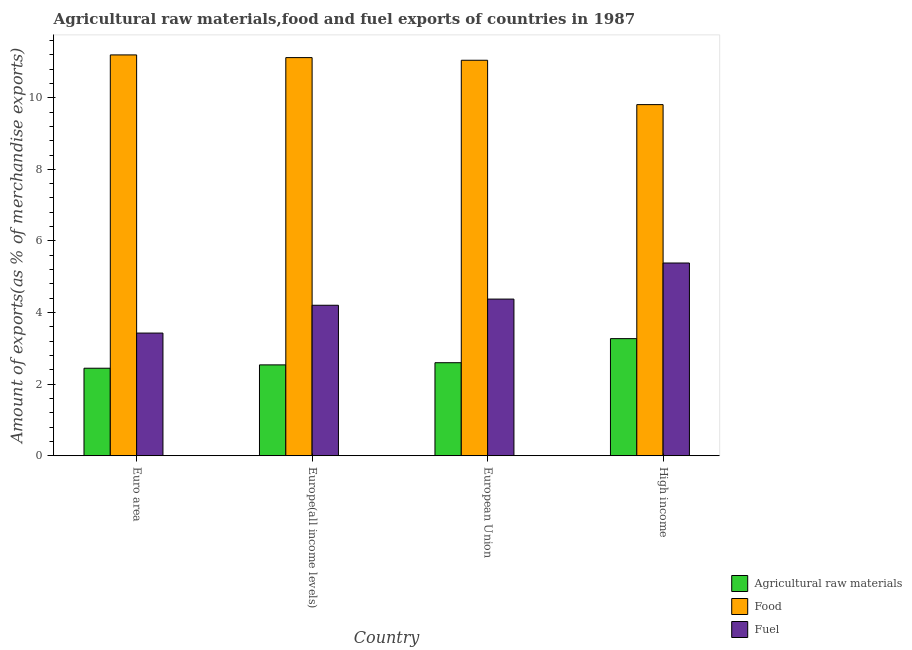How many different coloured bars are there?
Offer a very short reply. 3. Are the number of bars per tick equal to the number of legend labels?
Your answer should be compact. Yes. In how many cases, is the number of bars for a given country not equal to the number of legend labels?
Make the answer very short. 0. What is the percentage of raw materials exports in High income?
Provide a succinct answer. 3.27. Across all countries, what is the maximum percentage of fuel exports?
Keep it short and to the point. 5.38. Across all countries, what is the minimum percentage of food exports?
Offer a terse response. 9.81. In which country was the percentage of fuel exports maximum?
Provide a short and direct response. High income. In which country was the percentage of fuel exports minimum?
Ensure brevity in your answer.  Euro area. What is the total percentage of fuel exports in the graph?
Your answer should be compact. 17.39. What is the difference between the percentage of raw materials exports in Europe(all income levels) and that in High income?
Offer a very short reply. -0.73. What is the difference between the percentage of raw materials exports in European Union and the percentage of fuel exports in Europe(all income levels)?
Offer a very short reply. -1.6. What is the average percentage of food exports per country?
Your response must be concise. 10.79. What is the difference between the percentage of food exports and percentage of fuel exports in European Union?
Provide a succinct answer. 6.67. In how many countries, is the percentage of food exports greater than 8.4 %?
Give a very brief answer. 4. What is the ratio of the percentage of food exports in Europe(all income levels) to that in European Union?
Give a very brief answer. 1.01. Is the percentage of raw materials exports in European Union less than that in High income?
Offer a terse response. Yes. What is the difference between the highest and the second highest percentage of fuel exports?
Keep it short and to the point. 1.01. What is the difference between the highest and the lowest percentage of raw materials exports?
Ensure brevity in your answer.  0.83. What does the 2nd bar from the left in Euro area represents?
Ensure brevity in your answer.  Food. What does the 2nd bar from the right in High income represents?
Provide a succinct answer. Food. How many bars are there?
Offer a very short reply. 12. How many countries are there in the graph?
Your answer should be very brief. 4. What is the difference between two consecutive major ticks on the Y-axis?
Provide a succinct answer. 2. Where does the legend appear in the graph?
Make the answer very short. Bottom right. What is the title of the graph?
Provide a succinct answer. Agricultural raw materials,food and fuel exports of countries in 1987. Does "Poland" appear as one of the legend labels in the graph?
Keep it short and to the point. No. What is the label or title of the Y-axis?
Your response must be concise. Amount of exports(as % of merchandise exports). What is the Amount of exports(as % of merchandise exports) in Agricultural raw materials in Euro area?
Ensure brevity in your answer.  2.44. What is the Amount of exports(as % of merchandise exports) in Food in Euro area?
Ensure brevity in your answer.  11.2. What is the Amount of exports(as % of merchandise exports) in Fuel in Euro area?
Keep it short and to the point. 3.43. What is the Amount of exports(as % of merchandise exports) in Agricultural raw materials in Europe(all income levels)?
Your answer should be very brief. 2.54. What is the Amount of exports(as % of merchandise exports) of Food in Europe(all income levels)?
Make the answer very short. 11.12. What is the Amount of exports(as % of merchandise exports) of Fuel in Europe(all income levels)?
Offer a terse response. 4.2. What is the Amount of exports(as % of merchandise exports) in Agricultural raw materials in European Union?
Provide a short and direct response. 2.6. What is the Amount of exports(as % of merchandise exports) of Food in European Union?
Make the answer very short. 11.05. What is the Amount of exports(as % of merchandise exports) in Fuel in European Union?
Offer a terse response. 4.38. What is the Amount of exports(as % of merchandise exports) in Agricultural raw materials in High income?
Offer a terse response. 3.27. What is the Amount of exports(as % of merchandise exports) of Food in High income?
Provide a succinct answer. 9.81. What is the Amount of exports(as % of merchandise exports) in Fuel in High income?
Your answer should be compact. 5.38. Across all countries, what is the maximum Amount of exports(as % of merchandise exports) of Agricultural raw materials?
Give a very brief answer. 3.27. Across all countries, what is the maximum Amount of exports(as % of merchandise exports) in Food?
Offer a terse response. 11.2. Across all countries, what is the maximum Amount of exports(as % of merchandise exports) of Fuel?
Keep it short and to the point. 5.38. Across all countries, what is the minimum Amount of exports(as % of merchandise exports) of Agricultural raw materials?
Keep it short and to the point. 2.44. Across all countries, what is the minimum Amount of exports(as % of merchandise exports) of Food?
Offer a terse response. 9.81. Across all countries, what is the minimum Amount of exports(as % of merchandise exports) in Fuel?
Make the answer very short. 3.43. What is the total Amount of exports(as % of merchandise exports) in Agricultural raw materials in the graph?
Keep it short and to the point. 10.85. What is the total Amount of exports(as % of merchandise exports) of Food in the graph?
Offer a terse response. 43.17. What is the total Amount of exports(as % of merchandise exports) in Fuel in the graph?
Your response must be concise. 17.39. What is the difference between the Amount of exports(as % of merchandise exports) in Agricultural raw materials in Euro area and that in Europe(all income levels)?
Provide a short and direct response. -0.09. What is the difference between the Amount of exports(as % of merchandise exports) of Food in Euro area and that in Europe(all income levels)?
Provide a short and direct response. 0.07. What is the difference between the Amount of exports(as % of merchandise exports) of Fuel in Euro area and that in Europe(all income levels)?
Ensure brevity in your answer.  -0.78. What is the difference between the Amount of exports(as % of merchandise exports) of Agricultural raw materials in Euro area and that in European Union?
Provide a short and direct response. -0.15. What is the difference between the Amount of exports(as % of merchandise exports) of Food in Euro area and that in European Union?
Provide a short and direct response. 0.15. What is the difference between the Amount of exports(as % of merchandise exports) of Fuel in Euro area and that in European Union?
Offer a very short reply. -0.95. What is the difference between the Amount of exports(as % of merchandise exports) in Agricultural raw materials in Euro area and that in High income?
Ensure brevity in your answer.  -0.83. What is the difference between the Amount of exports(as % of merchandise exports) in Food in Euro area and that in High income?
Provide a succinct answer. 1.39. What is the difference between the Amount of exports(as % of merchandise exports) in Fuel in Euro area and that in High income?
Offer a very short reply. -1.96. What is the difference between the Amount of exports(as % of merchandise exports) in Agricultural raw materials in Europe(all income levels) and that in European Union?
Offer a very short reply. -0.06. What is the difference between the Amount of exports(as % of merchandise exports) in Food in Europe(all income levels) and that in European Union?
Give a very brief answer. 0.07. What is the difference between the Amount of exports(as % of merchandise exports) in Fuel in Europe(all income levels) and that in European Union?
Offer a very short reply. -0.17. What is the difference between the Amount of exports(as % of merchandise exports) of Agricultural raw materials in Europe(all income levels) and that in High income?
Offer a very short reply. -0.73. What is the difference between the Amount of exports(as % of merchandise exports) in Food in Europe(all income levels) and that in High income?
Make the answer very short. 1.31. What is the difference between the Amount of exports(as % of merchandise exports) of Fuel in Europe(all income levels) and that in High income?
Keep it short and to the point. -1.18. What is the difference between the Amount of exports(as % of merchandise exports) of Agricultural raw materials in European Union and that in High income?
Keep it short and to the point. -0.67. What is the difference between the Amount of exports(as % of merchandise exports) of Food in European Union and that in High income?
Provide a succinct answer. 1.24. What is the difference between the Amount of exports(as % of merchandise exports) in Fuel in European Union and that in High income?
Keep it short and to the point. -1.01. What is the difference between the Amount of exports(as % of merchandise exports) of Agricultural raw materials in Euro area and the Amount of exports(as % of merchandise exports) of Food in Europe(all income levels)?
Make the answer very short. -8.68. What is the difference between the Amount of exports(as % of merchandise exports) in Agricultural raw materials in Euro area and the Amount of exports(as % of merchandise exports) in Fuel in Europe(all income levels)?
Keep it short and to the point. -1.76. What is the difference between the Amount of exports(as % of merchandise exports) of Food in Euro area and the Amount of exports(as % of merchandise exports) of Fuel in Europe(all income levels)?
Your answer should be compact. 6.99. What is the difference between the Amount of exports(as % of merchandise exports) in Agricultural raw materials in Euro area and the Amount of exports(as % of merchandise exports) in Food in European Union?
Give a very brief answer. -8.6. What is the difference between the Amount of exports(as % of merchandise exports) of Agricultural raw materials in Euro area and the Amount of exports(as % of merchandise exports) of Fuel in European Union?
Give a very brief answer. -1.93. What is the difference between the Amount of exports(as % of merchandise exports) in Food in Euro area and the Amount of exports(as % of merchandise exports) in Fuel in European Union?
Your response must be concise. 6.82. What is the difference between the Amount of exports(as % of merchandise exports) in Agricultural raw materials in Euro area and the Amount of exports(as % of merchandise exports) in Food in High income?
Ensure brevity in your answer.  -7.36. What is the difference between the Amount of exports(as % of merchandise exports) of Agricultural raw materials in Euro area and the Amount of exports(as % of merchandise exports) of Fuel in High income?
Give a very brief answer. -2.94. What is the difference between the Amount of exports(as % of merchandise exports) in Food in Euro area and the Amount of exports(as % of merchandise exports) in Fuel in High income?
Your answer should be compact. 5.81. What is the difference between the Amount of exports(as % of merchandise exports) of Agricultural raw materials in Europe(all income levels) and the Amount of exports(as % of merchandise exports) of Food in European Union?
Keep it short and to the point. -8.51. What is the difference between the Amount of exports(as % of merchandise exports) of Agricultural raw materials in Europe(all income levels) and the Amount of exports(as % of merchandise exports) of Fuel in European Union?
Ensure brevity in your answer.  -1.84. What is the difference between the Amount of exports(as % of merchandise exports) of Food in Europe(all income levels) and the Amount of exports(as % of merchandise exports) of Fuel in European Union?
Your answer should be very brief. 6.75. What is the difference between the Amount of exports(as % of merchandise exports) in Agricultural raw materials in Europe(all income levels) and the Amount of exports(as % of merchandise exports) in Food in High income?
Keep it short and to the point. -7.27. What is the difference between the Amount of exports(as % of merchandise exports) in Agricultural raw materials in Europe(all income levels) and the Amount of exports(as % of merchandise exports) in Fuel in High income?
Your answer should be very brief. -2.85. What is the difference between the Amount of exports(as % of merchandise exports) of Food in Europe(all income levels) and the Amount of exports(as % of merchandise exports) of Fuel in High income?
Provide a short and direct response. 5.74. What is the difference between the Amount of exports(as % of merchandise exports) in Agricultural raw materials in European Union and the Amount of exports(as % of merchandise exports) in Food in High income?
Offer a very short reply. -7.21. What is the difference between the Amount of exports(as % of merchandise exports) of Agricultural raw materials in European Union and the Amount of exports(as % of merchandise exports) of Fuel in High income?
Your answer should be very brief. -2.78. What is the difference between the Amount of exports(as % of merchandise exports) in Food in European Union and the Amount of exports(as % of merchandise exports) in Fuel in High income?
Offer a terse response. 5.66. What is the average Amount of exports(as % of merchandise exports) in Agricultural raw materials per country?
Your response must be concise. 2.71. What is the average Amount of exports(as % of merchandise exports) in Food per country?
Give a very brief answer. 10.79. What is the average Amount of exports(as % of merchandise exports) in Fuel per country?
Your answer should be very brief. 4.35. What is the difference between the Amount of exports(as % of merchandise exports) of Agricultural raw materials and Amount of exports(as % of merchandise exports) of Food in Euro area?
Provide a short and direct response. -8.75. What is the difference between the Amount of exports(as % of merchandise exports) of Agricultural raw materials and Amount of exports(as % of merchandise exports) of Fuel in Euro area?
Provide a short and direct response. -0.98. What is the difference between the Amount of exports(as % of merchandise exports) of Food and Amount of exports(as % of merchandise exports) of Fuel in Euro area?
Your response must be concise. 7.77. What is the difference between the Amount of exports(as % of merchandise exports) of Agricultural raw materials and Amount of exports(as % of merchandise exports) of Food in Europe(all income levels)?
Make the answer very short. -8.58. What is the difference between the Amount of exports(as % of merchandise exports) of Agricultural raw materials and Amount of exports(as % of merchandise exports) of Fuel in Europe(all income levels)?
Offer a very short reply. -1.67. What is the difference between the Amount of exports(as % of merchandise exports) of Food and Amount of exports(as % of merchandise exports) of Fuel in Europe(all income levels)?
Ensure brevity in your answer.  6.92. What is the difference between the Amount of exports(as % of merchandise exports) in Agricultural raw materials and Amount of exports(as % of merchandise exports) in Food in European Union?
Your response must be concise. -8.45. What is the difference between the Amount of exports(as % of merchandise exports) in Agricultural raw materials and Amount of exports(as % of merchandise exports) in Fuel in European Union?
Give a very brief answer. -1.78. What is the difference between the Amount of exports(as % of merchandise exports) of Food and Amount of exports(as % of merchandise exports) of Fuel in European Union?
Offer a very short reply. 6.67. What is the difference between the Amount of exports(as % of merchandise exports) of Agricultural raw materials and Amount of exports(as % of merchandise exports) of Food in High income?
Provide a succinct answer. -6.54. What is the difference between the Amount of exports(as % of merchandise exports) of Agricultural raw materials and Amount of exports(as % of merchandise exports) of Fuel in High income?
Your answer should be very brief. -2.11. What is the difference between the Amount of exports(as % of merchandise exports) of Food and Amount of exports(as % of merchandise exports) of Fuel in High income?
Offer a terse response. 4.42. What is the ratio of the Amount of exports(as % of merchandise exports) in Agricultural raw materials in Euro area to that in Europe(all income levels)?
Offer a very short reply. 0.96. What is the ratio of the Amount of exports(as % of merchandise exports) of Food in Euro area to that in Europe(all income levels)?
Give a very brief answer. 1.01. What is the ratio of the Amount of exports(as % of merchandise exports) in Fuel in Euro area to that in Europe(all income levels)?
Provide a short and direct response. 0.82. What is the ratio of the Amount of exports(as % of merchandise exports) in Agricultural raw materials in Euro area to that in European Union?
Provide a short and direct response. 0.94. What is the ratio of the Amount of exports(as % of merchandise exports) of Food in Euro area to that in European Union?
Give a very brief answer. 1.01. What is the ratio of the Amount of exports(as % of merchandise exports) in Fuel in Euro area to that in European Union?
Give a very brief answer. 0.78. What is the ratio of the Amount of exports(as % of merchandise exports) in Agricultural raw materials in Euro area to that in High income?
Make the answer very short. 0.75. What is the ratio of the Amount of exports(as % of merchandise exports) of Food in Euro area to that in High income?
Your answer should be very brief. 1.14. What is the ratio of the Amount of exports(as % of merchandise exports) in Fuel in Euro area to that in High income?
Keep it short and to the point. 0.64. What is the ratio of the Amount of exports(as % of merchandise exports) in Agricultural raw materials in Europe(all income levels) to that in European Union?
Give a very brief answer. 0.98. What is the ratio of the Amount of exports(as % of merchandise exports) in Food in Europe(all income levels) to that in European Union?
Make the answer very short. 1.01. What is the ratio of the Amount of exports(as % of merchandise exports) of Fuel in Europe(all income levels) to that in European Union?
Ensure brevity in your answer.  0.96. What is the ratio of the Amount of exports(as % of merchandise exports) of Agricultural raw materials in Europe(all income levels) to that in High income?
Offer a very short reply. 0.78. What is the ratio of the Amount of exports(as % of merchandise exports) of Food in Europe(all income levels) to that in High income?
Offer a very short reply. 1.13. What is the ratio of the Amount of exports(as % of merchandise exports) in Fuel in Europe(all income levels) to that in High income?
Make the answer very short. 0.78. What is the ratio of the Amount of exports(as % of merchandise exports) in Agricultural raw materials in European Union to that in High income?
Keep it short and to the point. 0.79. What is the ratio of the Amount of exports(as % of merchandise exports) of Food in European Union to that in High income?
Keep it short and to the point. 1.13. What is the ratio of the Amount of exports(as % of merchandise exports) of Fuel in European Union to that in High income?
Your answer should be compact. 0.81. What is the difference between the highest and the second highest Amount of exports(as % of merchandise exports) in Agricultural raw materials?
Offer a terse response. 0.67. What is the difference between the highest and the second highest Amount of exports(as % of merchandise exports) of Food?
Your answer should be very brief. 0.07. What is the difference between the highest and the second highest Amount of exports(as % of merchandise exports) of Fuel?
Offer a very short reply. 1.01. What is the difference between the highest and the lowest Amount of exports(as % of merchandise exports) of Agricultural raw materials?
Provide a succinct answer. 0.83. What is the difference between the highest and the lowest Amount of exports(as % of merchandise exports) in Food?
Provide a short and direct response. 1.39. What is the difference between the highest and the lowest Amount of exports(as % of merchandise exports) of Fuel?
Your response must be concise. 1.96. 